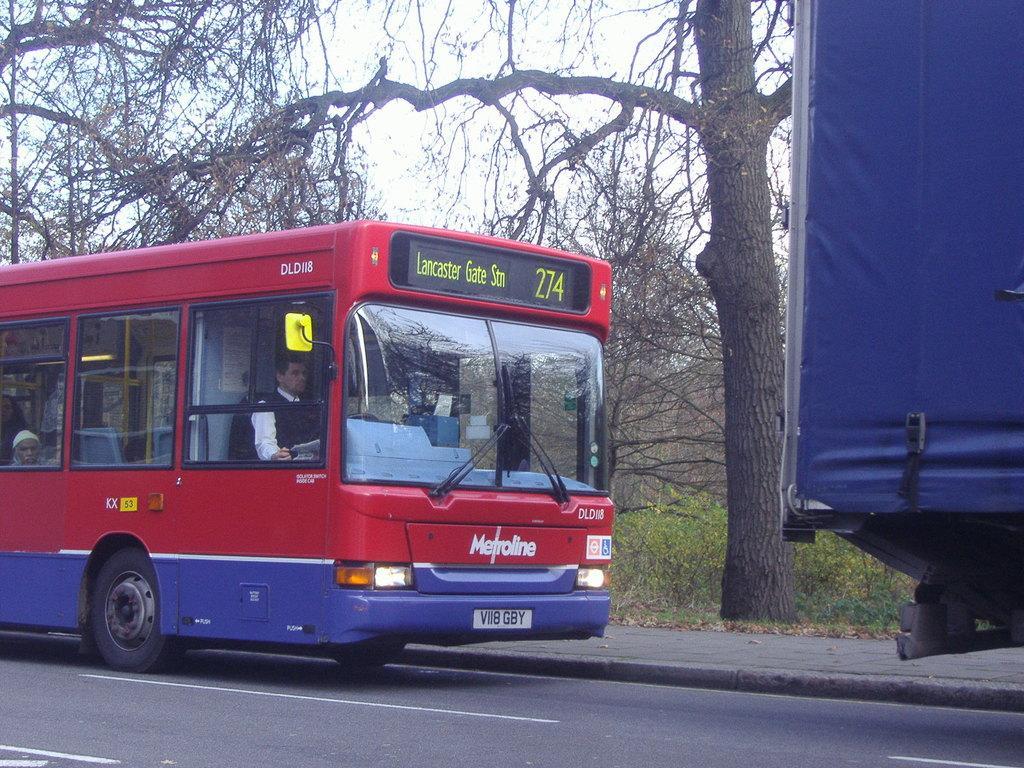Please provide a concise description of this image. In this image, people are riding a bus on the road. On the right side, we can see blue color object. Background there is a walkway, trees, plants and sky. 